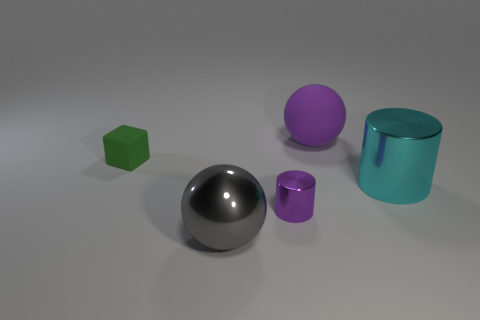Add 2 big cyan metallic cubes. How many objects exist? 7 Subtract all spheres. How many objects are left? 3 Subtract all large purple rubber objects. Subtract all tiny blocks. How many objects are left? 3 Add 4 big cyan cylinders. How many big cyan cylinders are left? 5 Add 3 big shiny spheres. How many big shiny spheres exist? 4 Subtract 0 gray cylinders. How many objects are left? 5 